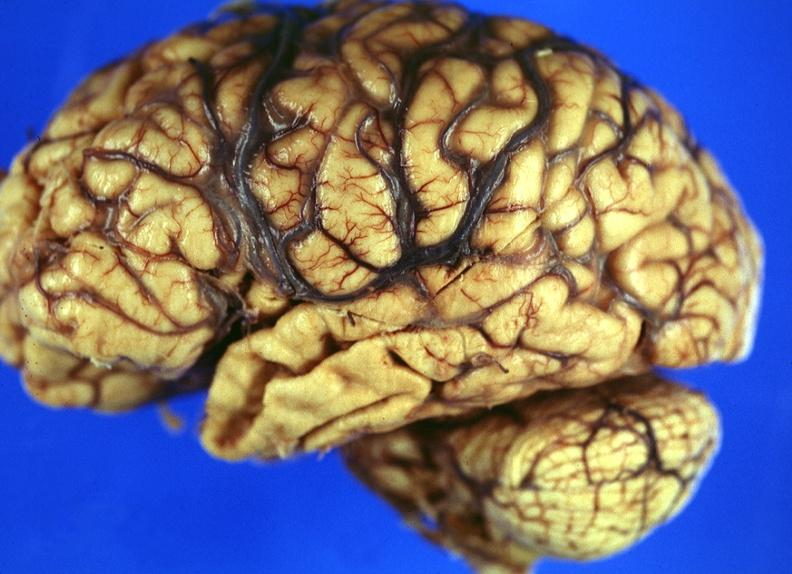what is present?
Answer the question using a single word or phrase. Nervous 